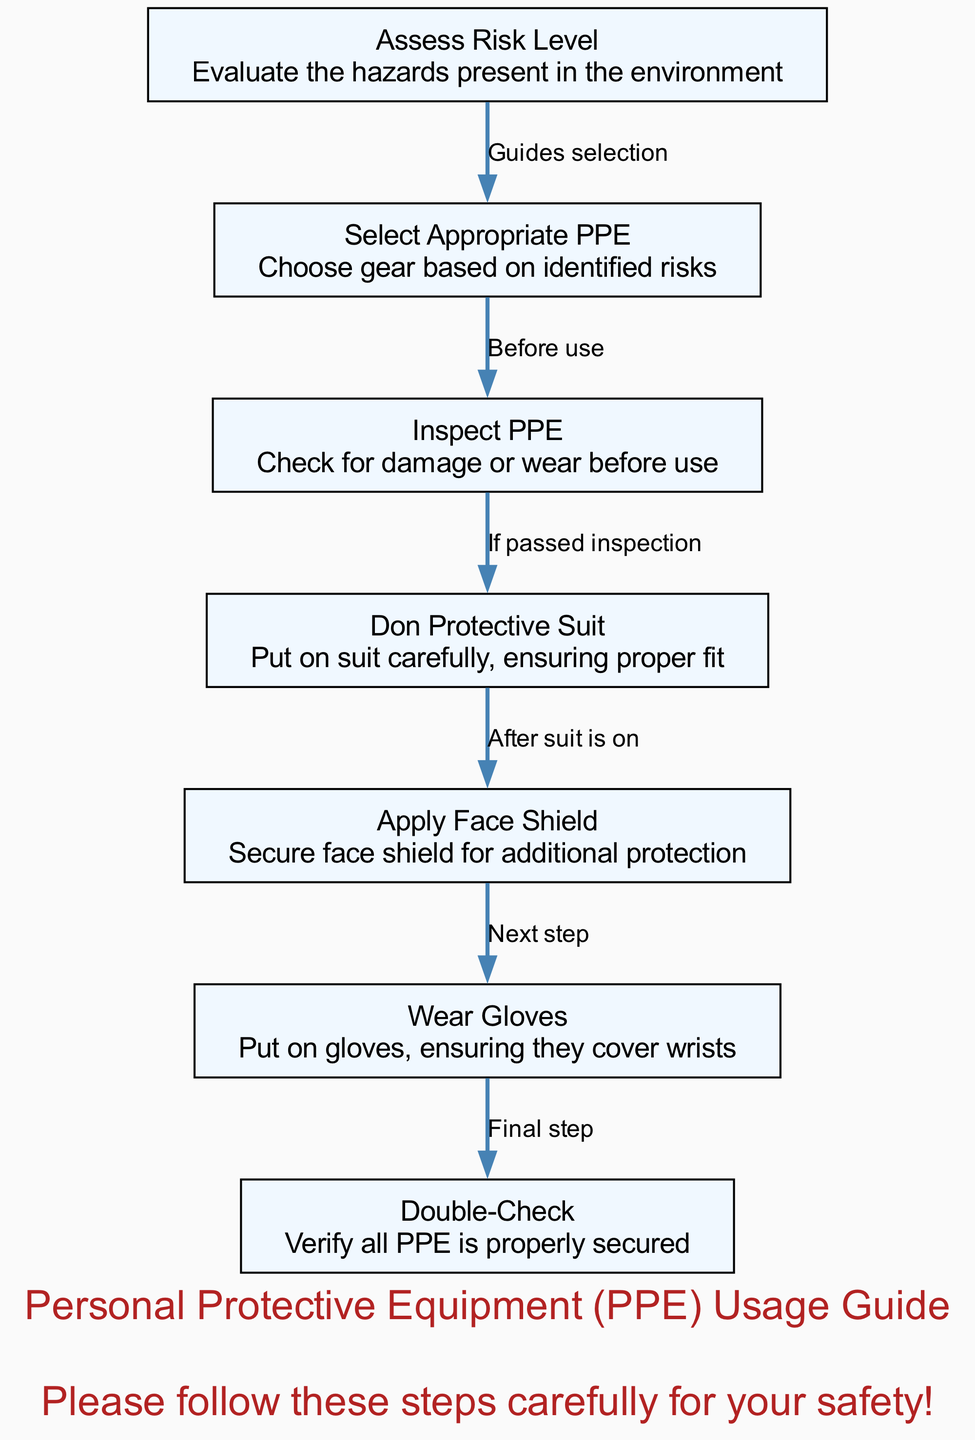What is the first step in the PPE usage process? The diagram clearly indicates that the first step is labeled "Assess Risk Level," which is the initial node in the flow of the PPE usage guide.
Answer: Assess Risk Level How many total nodes are present in the diagram? By counting each unique step or action represented in the diagram, we find there are a total of 7 nodes involved in the process of proper PPE usage.
Answer: 7 What step follows after "Inspect PPE"? Looking at the flow of the diagram, the step that directly follows "Inspect PPE" is "Don Protective Suit," which indicates the sequence after checking the PPE condition.
Answer: Don Protective Suit What does the edge from "Select Appropriate PPE" to "Inspect PPE" represent? The edge signifies a guide that indicates that selecting the appropriate personal protective equipment should be done before inspecting it for damage or wear.
Answer: Guides selection What is the last step before exiting the PPE usage process? The final step before completing the PPE usage process is "Double-Check," where the user verifies that all PPE is correctly secured for safety.
Answer: Double-Check What is the description of the node labeled "Apply Face Shield"? The description provided in the diagram for the "Apply Face Shield" node specifies that it is about securing the face shield for additional protection.
Answer: Secure face shield for additional protection What does the edge that connects "Wear Gloves" to "Double-Check" indicate? This edge indicates that wearing gloves is the final step before performing a double-check to ensure all PPE is properly secured.
Answer: Final step 